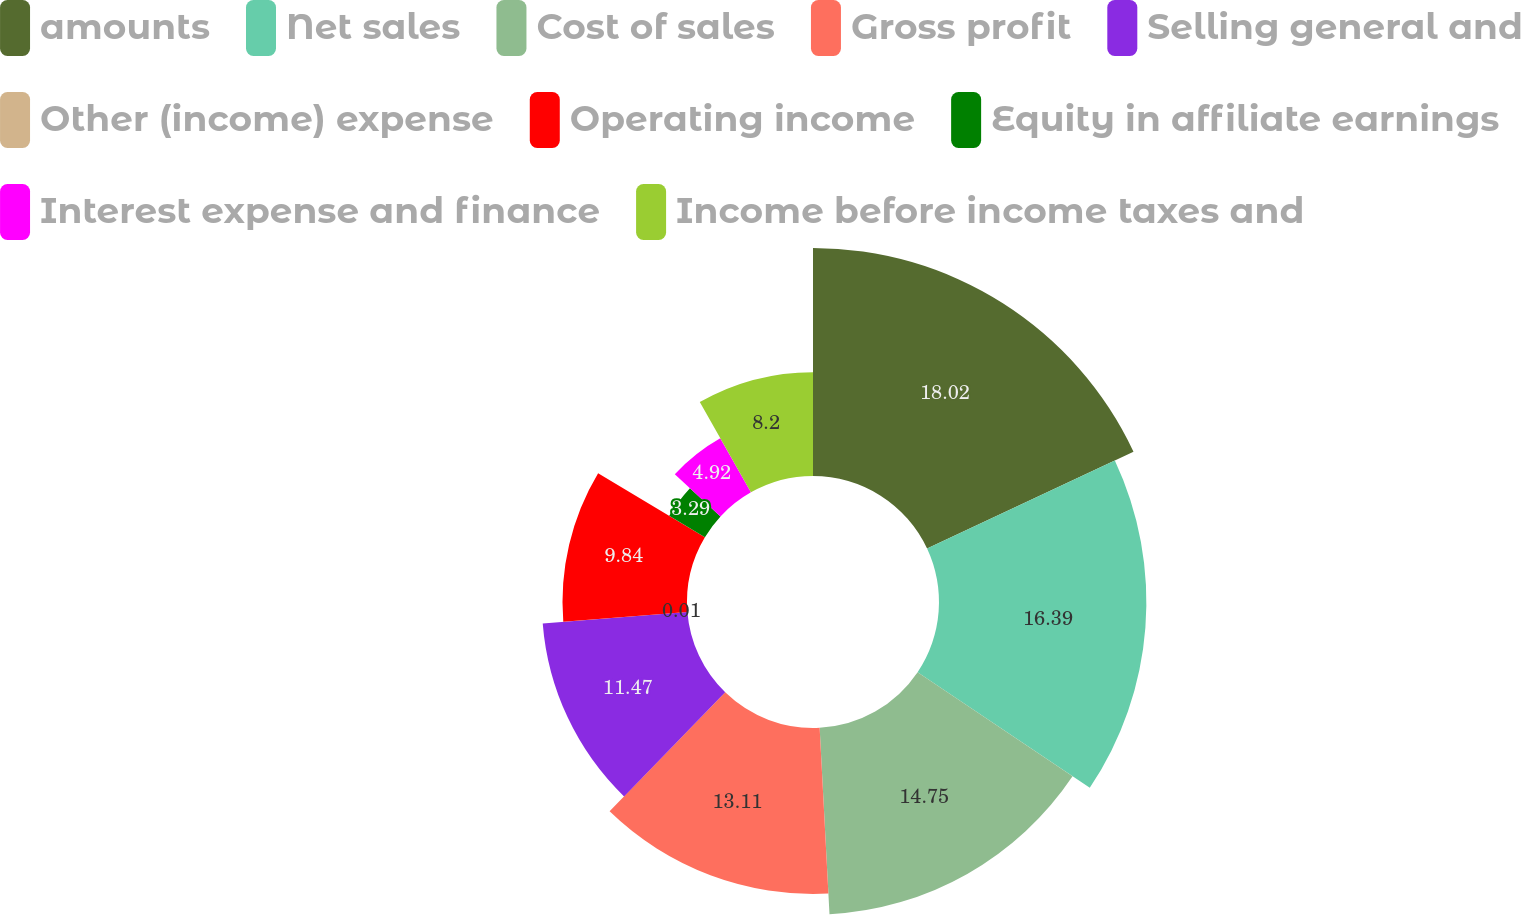Convert chart to OTSL. <chart><loc_0><loc_0><loc_500><loc_500><pie_chart><fcel>amounts<fcel>Net sales<fcel>Cost of sales<fcel>Gross profit<fcel>Selling general and<fcel>Other (income) expense<fcel>Operating income<fcel>Equity in affiliate earnings<fcel>Interest expense and finance<fcel>Income before income taxes and<nl><fcel>18.02%<fcel>16.39%<fcel>14.75%<fcel>13.11%<fcel>11.47%<fcel>0.01%<fcel>9.84%<fcel>3.29%<fcel>4.92%<fcel>8.2%<nl></chart> 